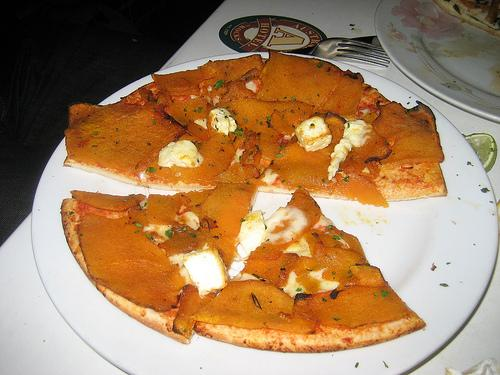What are the main objects in the image and their colors? The main objects are a silver fork, white table, pink flower, white plate, cooked pizza with toppings, and a cut lime. What type of cut is the lime in and where is it placed? The lime is cut into a slice and placed under the plate. What type of object is the plate made out of and is it on another object? The plate is made out of white ceramic and is on the table. How many types of cheese are visible on the pizza? Two types of cheese: a clump of white cheese and melted white cheese. Describe any visible logos or symbols in the image. There is a gold "a" on a symbol and a hotel logo on the table. What kind of clothing can be seen in the image? A person's blue jeans can be seen at the table. What is unusual or unique about the pizza in the image? The pizza has exotic toppings, including orange lox, and is cut into triangular slices. What position is the knife in relation to the fork on the table? The knife is behind the fork. Identify the color of the individual objects: fork, table, flower, and plate. The fork is silver, the table is white, the flower is pink, and the plate is white. Identify the various toppings and items on the pizza. The pizza has orange lox, goat cheese, green flakes, seasonings, and a parsley speck. Can you see a person's red shirt near the table? There is a mention of a person's blue jeans near the table but no mention of a red shirt. Does the pizza have green toppings? The pizza is mentioned to have orange toppings, white cheese, and exotic toppings, but there is no mention of green toppings. Is the knife in front of the fork? The knife is mentioned to be behind the fork, not in front of it. Is the tablecloth on the table blue? The table is mentioned to be white, and there is no mention of a tablecloth. Is the fork on the table gold-colored? The fork is mentioned to be silver, not gold. Is there a purple flower on the plate? The flower is mentioned to be pink, not purple. 